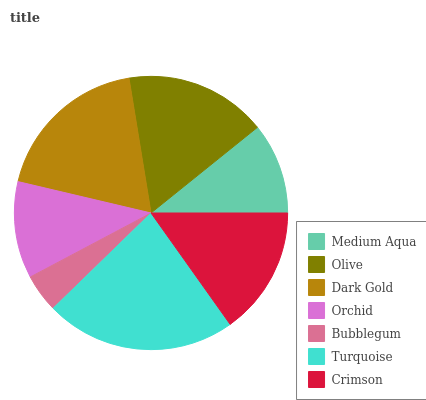Is Bubblegum the minimum?
Answer yes or no. Yes. Is Turquoise the maximum?
Answer yes or no. Yes. Is Olive the minimum?
Answer yes or no. No. Is Olive the maximum?
Answer yes or no. No. Is Olive greater than Medium Aqua?
Answer yes or no. Yes. Is Medium Aqua less than Olive?
Answer yes or no. Yes. Is Medium Aqua greater than Olive?
Answer yes or no. No. Is Olive less than Medium Aqua?
Answer yes or no. No. Is Crimson the high median?
Answer yes or no. Yes. Is Crimson the low median?
Answer yes or no. Yes. Is Orchid the high median?
Answer yes or no. No. Is Olive the low median?
Answer yes or no. No. 